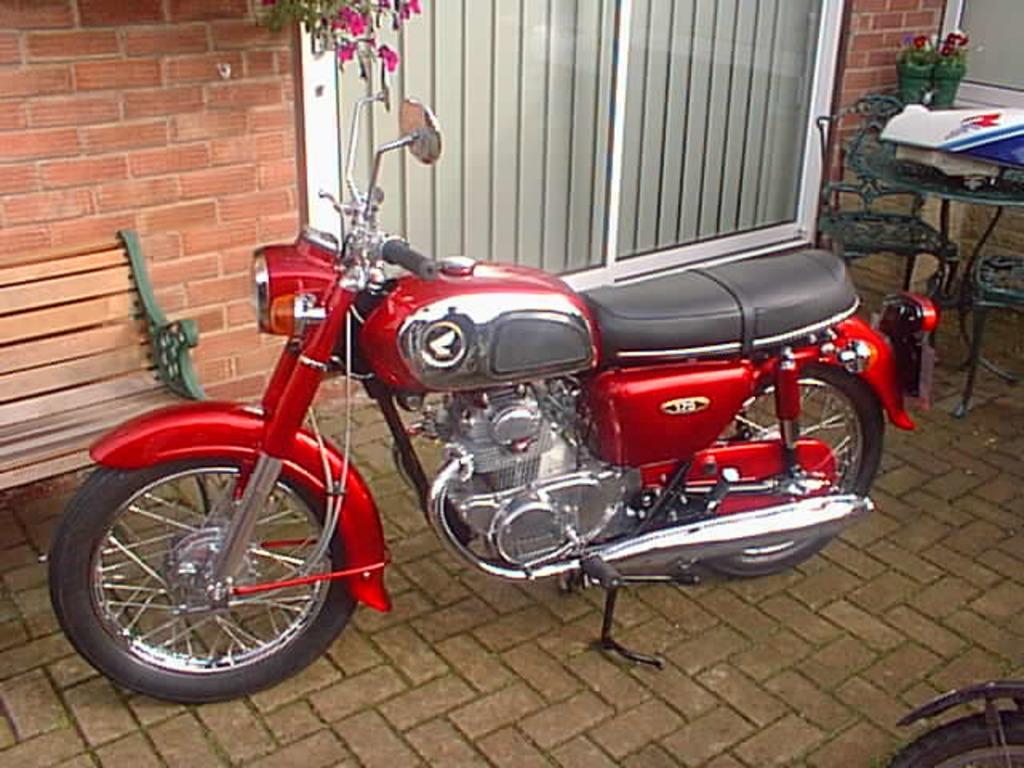Can you describe this image briefly? In the image in the center we can see one bike,which is in red color. In the background there is a brick wall,window,plant,bench,table,plant pots,files,chairs and few other objects. 